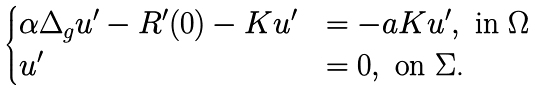Convert formula to latex. <formula><loc_0><loc_0><loc_500><loc_500>\begin{cases} \alpha \Delta _ { g } u ^ { \prime } - R ^ { \prime } ( 0 ) - K u ^ { \prime } & = - a K u ^ { \prime } , \text {\ in $\Omega$} \\ u ^ { \prime } & = 0 , \text {\ on $\Sigma$.} \end{cases}</formula> 